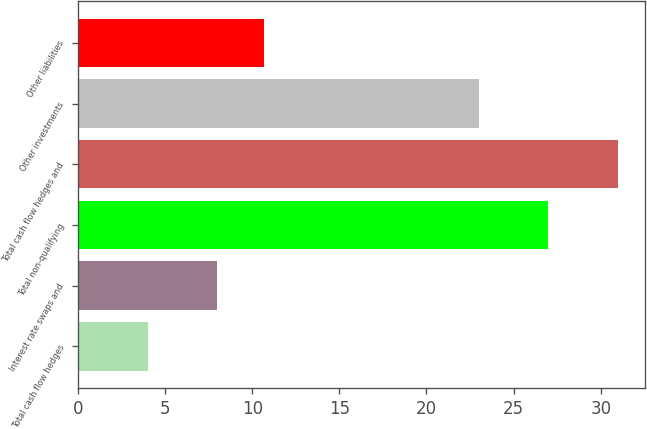Convert chart to OTSL. <chart><loc_0><loc_0><loc_500><loc_500><bar_chart><fcel>Total cash flow hedges<fcel>Interest rate swaps and<fcel>Total non-qualifying<fcel>Total cash flow hedges and<fcel>Other investments<fcel>Other liabilities<nl><fcel>4<fcel>8<fcel>27<fcel>31<fcel>23<fcel>10.7<nl></chart> 